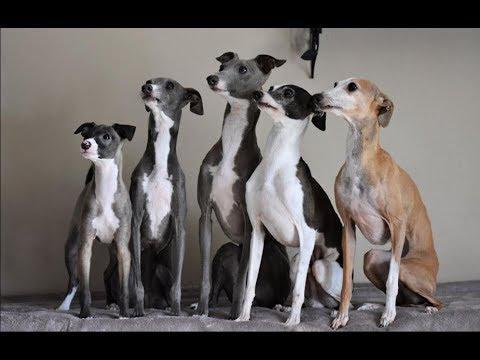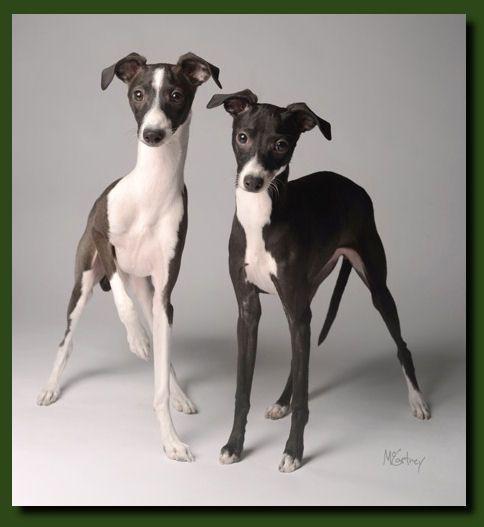The first image is the image on the left, the second image is the image on the right. Examine the images to the left and right. Is the description "One image contains five dogs." accurate? Answer yes or no. Yes. The first image is the image on the left, the second image is the image on the right. Examine the images to the left and right. Is the description "there are only two canines in the image on the right side" accurate? Answer yes or no. Yes. 